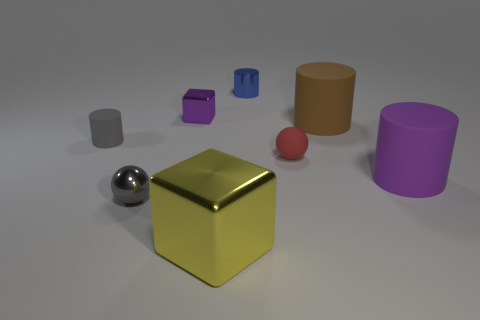Subtract all tiny blue cylinders. How many cylinders are left? 3 Add 1 red rubber things. How many objects exist? 9 Subtract all brown cylinders. How many cylinders are left? 3 Subtract 1 cylinders. How many cylinders are left? 3 Subtract all cyan cylinders. Subtract all gray cubes. How many cylinders are left? 4 Subtract all spheres. How many objects are left? 6 Add 4 gray metallic spheres. How many gray metallic spheres are left? 5 Add 4 yellow objects. How many yellow objects exist? 5 Subtract 0 cyan blocks. How many objects are left? 8 Subtract all small purple objects. Subtract all big yellow metal objects. How many objects are left? 6 